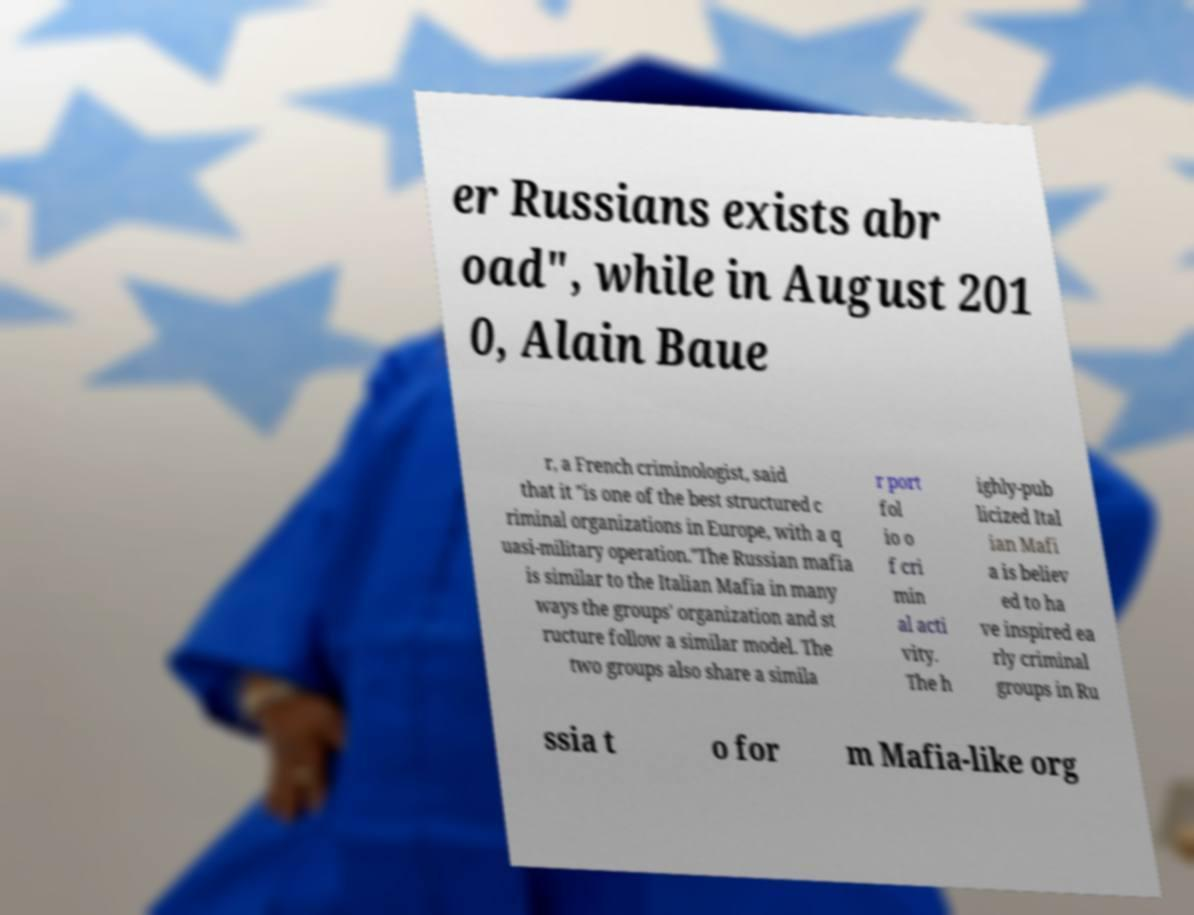Please read and relay the text visible in this image. What does it say? er Russians exists abr oad", while in August 201 0, Alain Baue r, a French criminologist, said that it "is one of the best structured c riminal organizations in Europe, with a q uasi-military operation."The Russian mafia is similar to the Italian Mafia in many ways the groups' organization and st ructure follow a similar model. The two groups also share a simila r port fol io o f cri min al acti vity. The h ighly-pub licized Ital ian Mafi a is believ ed to ha ve inspired ea rly criminal groups in Ru ssia t o for m Mafia-like org 